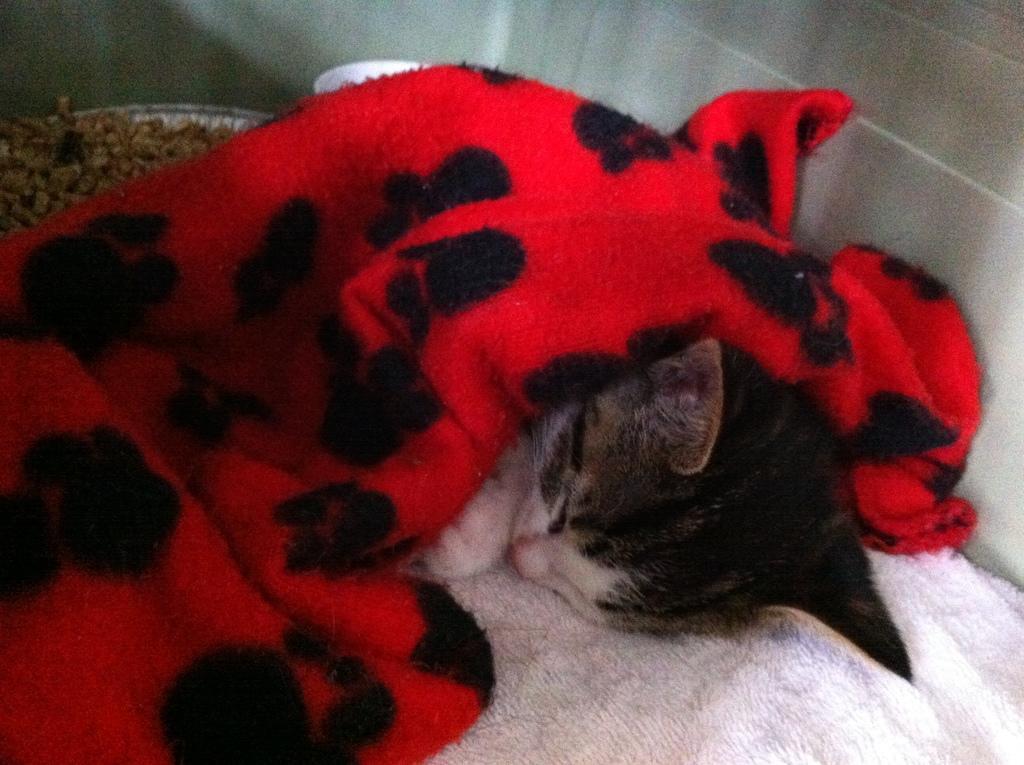Could you give a brief overview of what you see in this image? In this image we can see a cat sleeping on a couch and a cloth on the cat. 